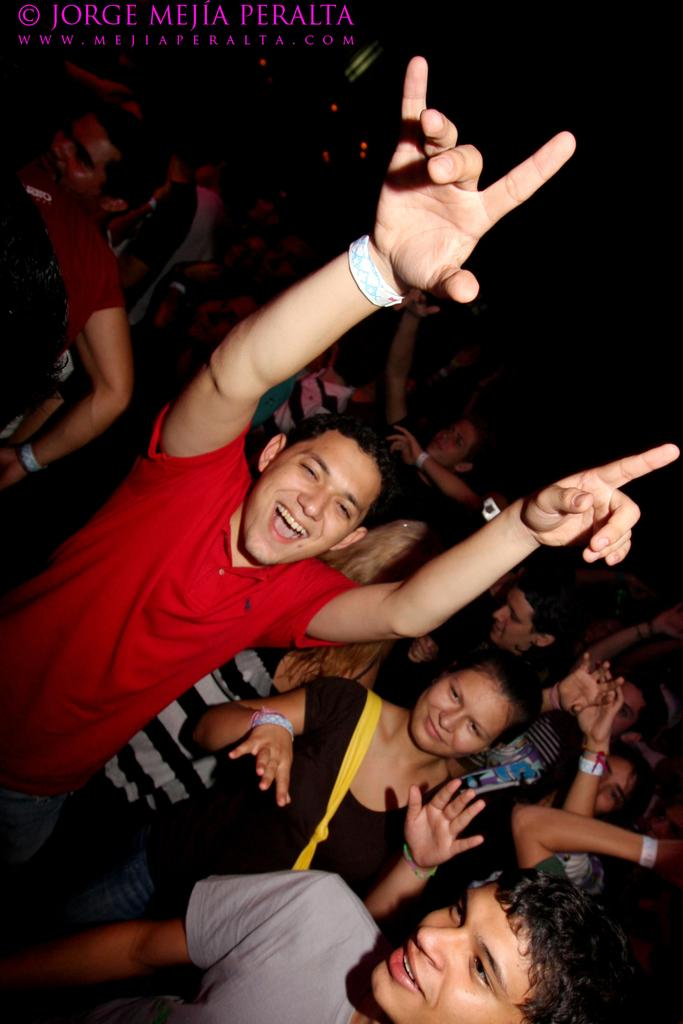Who is the main subject in the image? There is a man in the middle of the image. What is the man wearing? The man is wearing a red t-shirt. What is the man doing with his hands? The man has his two hands raised upward. What are the people in the background doing? The people in the background are dancing. Can you tell me where the goat is located in the image? There is no goat present in the image. What type of medical equipment can be seen in the image? There is no medical equipment or hospital setting depicted in the image. 